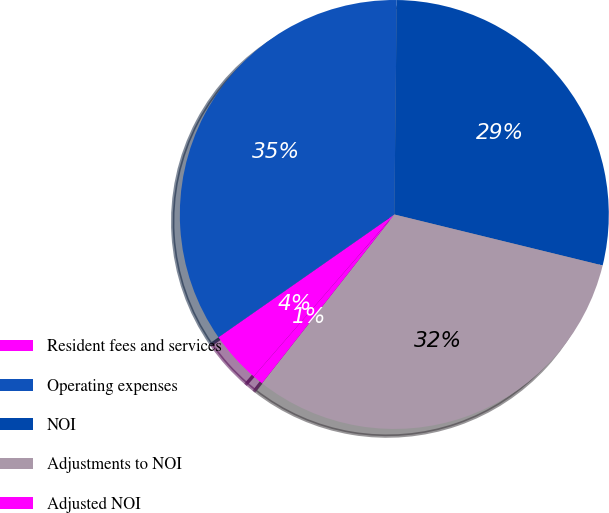<chart> <loc_0><loc_0><loc_500><loc_500><pie_chart><fcel>Resident fees and services<fcel>Operating expenses<fcel>NOI<fcel>Adjustments to NOI<fcel>Adjusted NOI<nl><fcel>3.92%<fcel>34.88%<fcel>28.64%<fcel>31.76%<fcel>0.8%<nl></chart> 